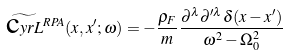Convert formula to latex. <formula><loc_0><loc_0><loc_500><loc_500>\widetilde { \text  cyr{L} } { ^ { R P A } } ( { x } , { x } ^ { \prime } ; \omega ) = - \frac { \rho _ { F } } { m } \frac { \partial ^ { \lambda } \partial ^ { \prime \lambda } \delta ( { x } - { x } ^ { \prime } ) } { \omega ^ { 2 } - \Omega _ { 0 } ^ { 2 } }</formula> 